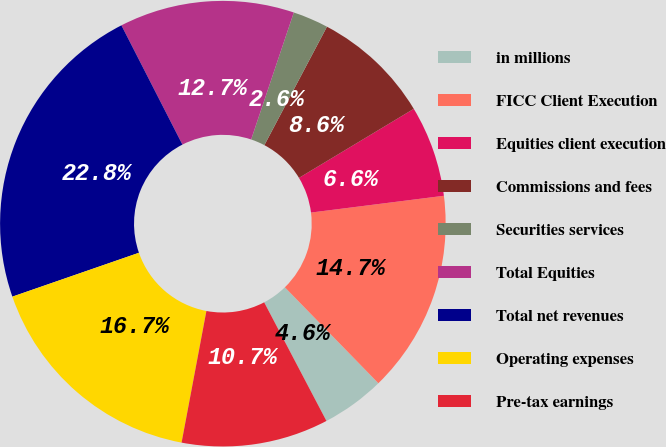<chart> <loc_0><loc_0><loc_500><loc_500><pie_chart><fcel>in millions<fcel>FICC Client Execution<fcel>Equities client execution<fcel>Commissions and fees<fcel>Securities services<fcel>Total Equities<fcel>Total net revenues<fcel>Operating expenses<fcel>Pre-tax earnings<nl><fcel>4.6%<fcel>14.7%<fcel>6.62%<fcel>8.64%<fcel>2.58%<fcel>12.68%<fcel>22.78%<fcel>16.72%<fcel>10.66%<nl></chart> 